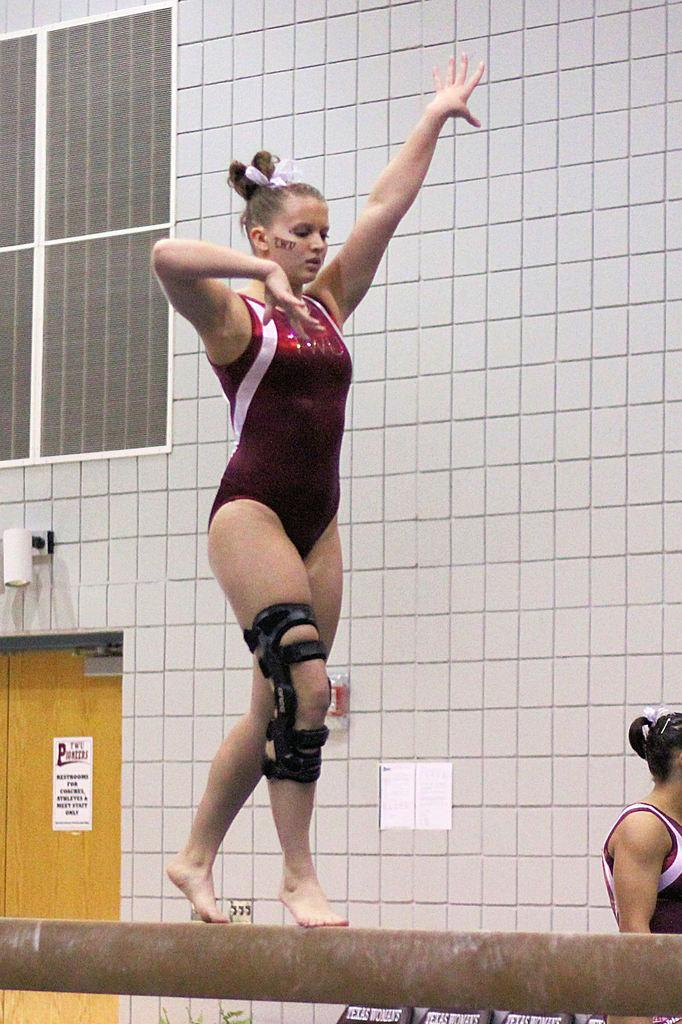What is the main activity being performed by the woman in the image? There is a woman performing gymnastics in the image. Are there any other people present in the image? Yes, there is another woman present in the image. What can be seen in the background of the image? There is a building visible in the image. Can you describe a specific feature of the building? There is a door in the image, which is a feature of the building. What type of boot is the woman wearing while performing gymnastics in the image? There is no boot mentioned or visible in the image; the woman is performing gymnastics without any footwear. 